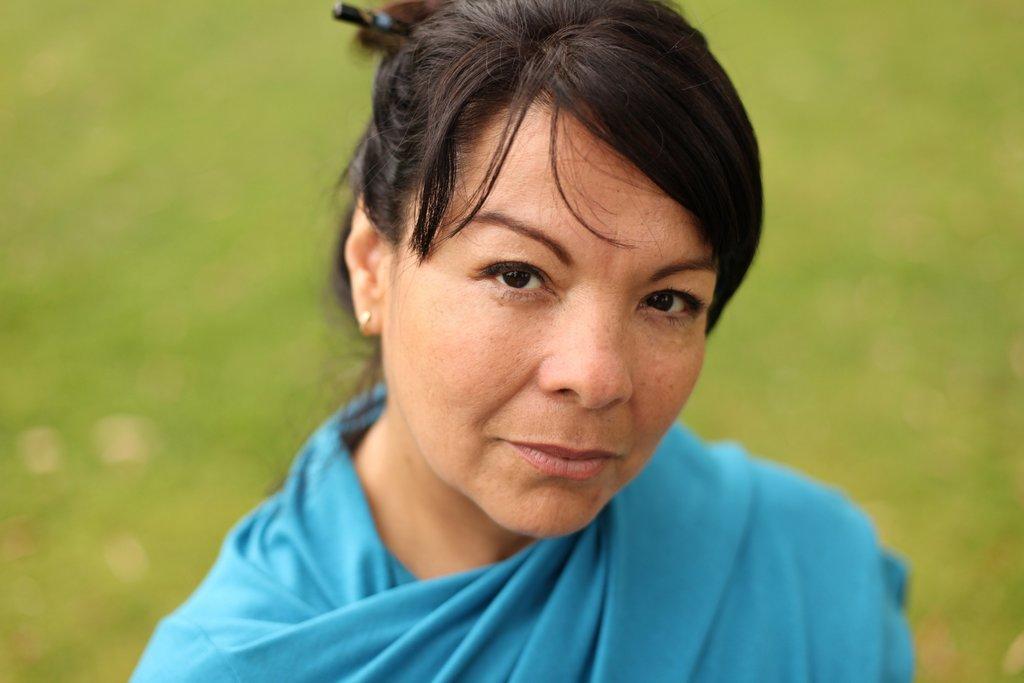Could you give a brief overview of what you see in this image? In this image I can see a person wearing a blue dress and the background is blurred. 